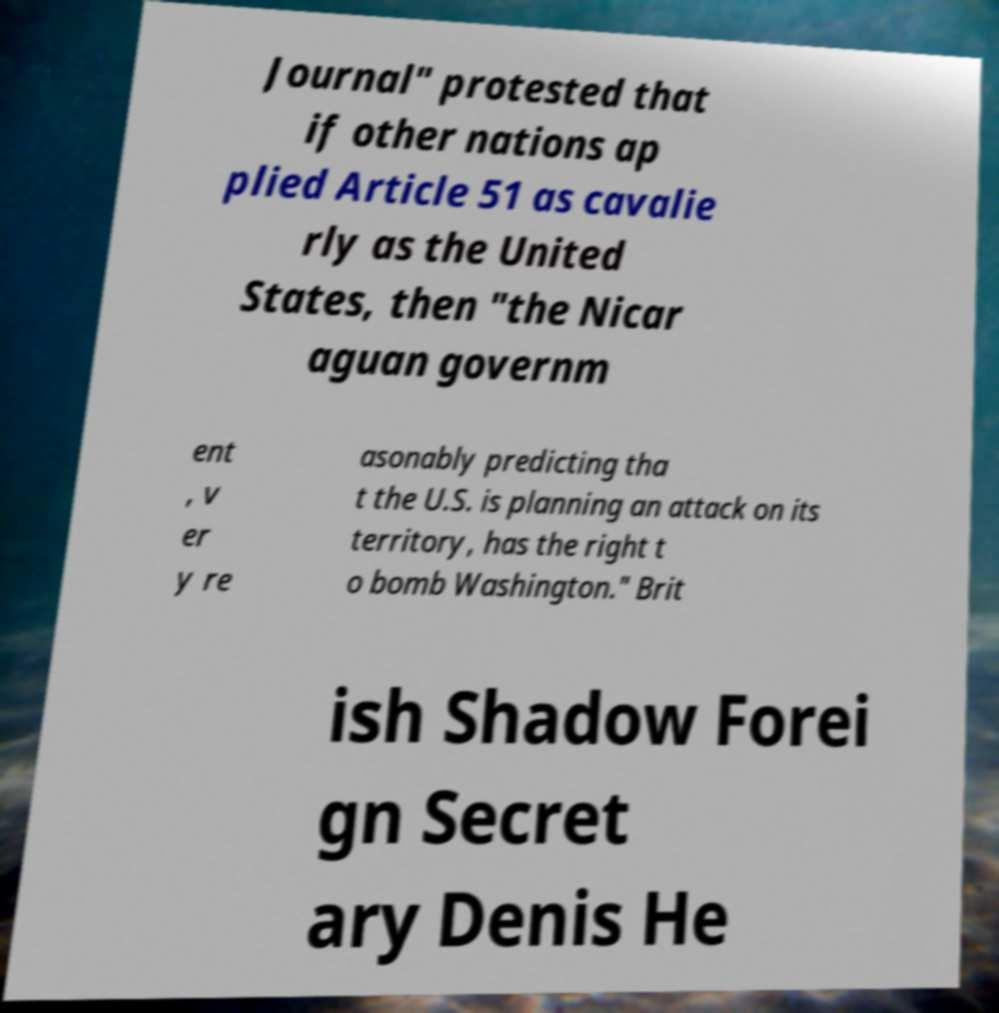Please read and relay the text visible in this image. What does it say? Journal" protested that if other nations ap plied Article 51 as cavalie rly as the United States, then "the Nicar aguan governm ent , v er y re asonably predicting tha t the U.S. is planning an attack on its territory, has the right t o bomb Washington." Brit ish Shadow Forei gn Secret ary Denis He 